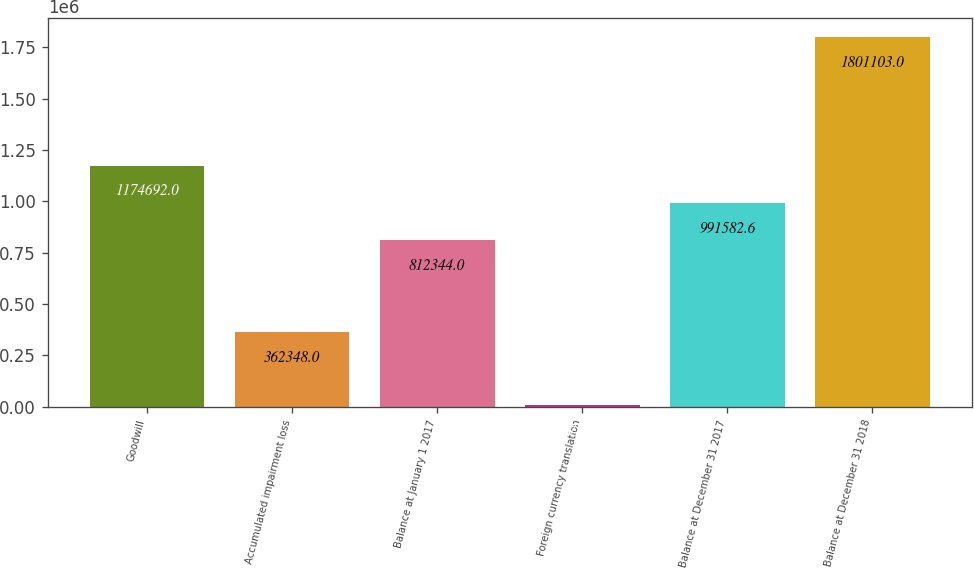Convert chart to OTSL. <chart><loc_0><loc_0><loc_500><loc_500><bar_chart><fcel>Goodwill<fcel>Accumulated impairment loss<fcel>Balance at January 1 2017<fcel>Foreign currency translation<fcel>Balance at December 31 2017<fcel>Balance at December 31 2018<nl><fcel>1.17469e+06<fcel>362348<fcel>812344<fcel>8717<fcel>991583<fcel>1.8011e+06<nl></chart> 